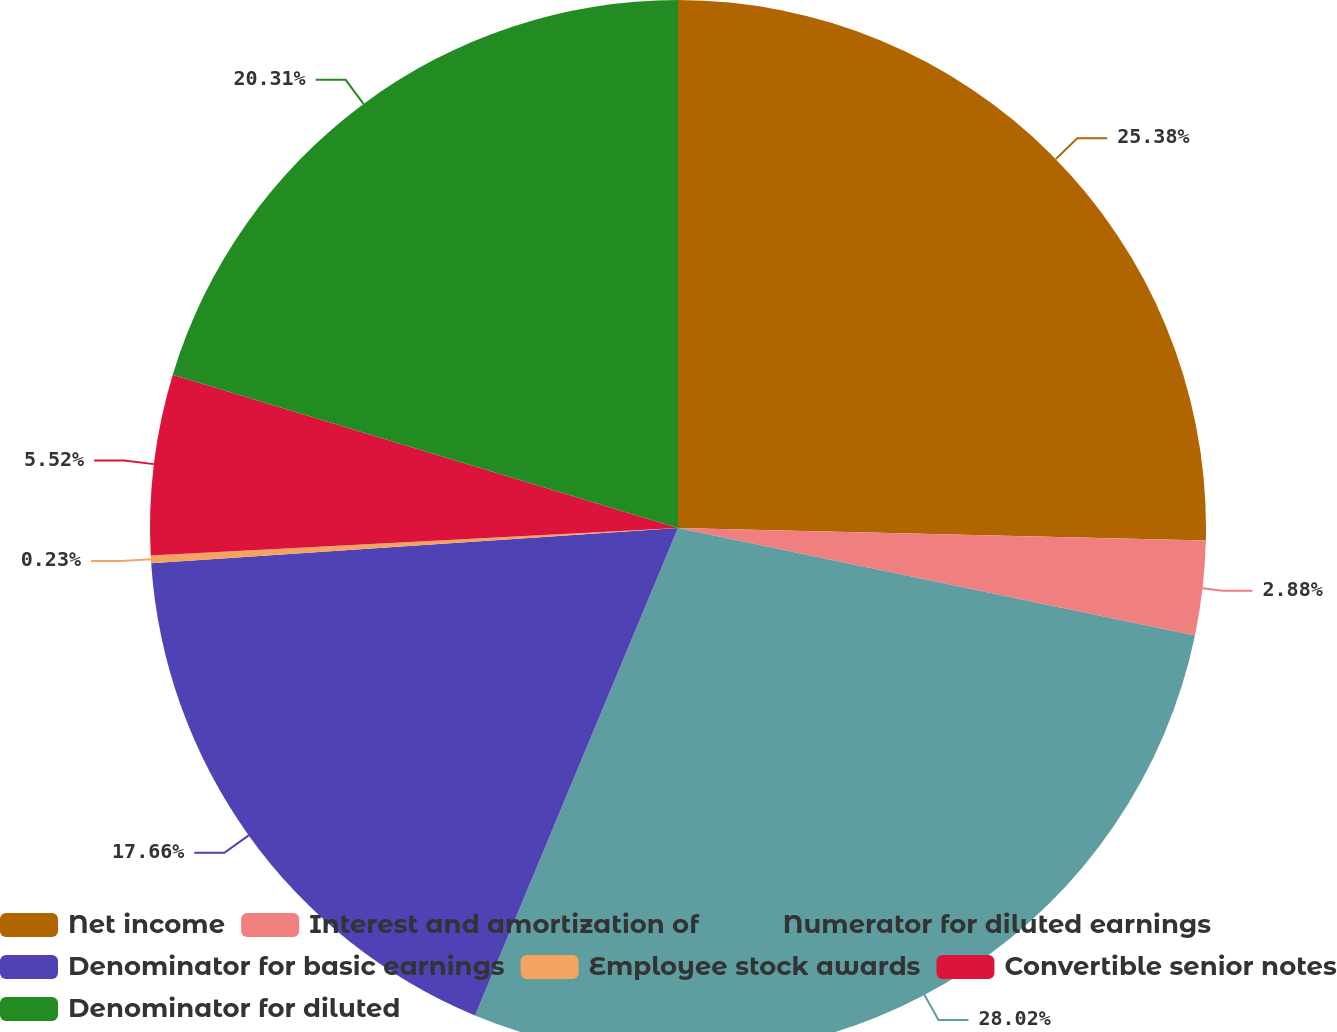<chart> <loc_0><loc_0><loc_500><loc_500><pie_chart><fcel>Net income<fcel>Interest and amortization of<fcel>Numerator for diluted earnings<fcel>Denominator for basic earnings<fcel>Employee stock awards<fcel>Convertible senior notes<fcel>Denominator for diluted<nl><fcel>25.38%<fcel>2.88%<fcel>28.02%<fcel>17.66%<fcel>0.23%<fcel>5.52%<fcel>20.31%<nl></chart> 